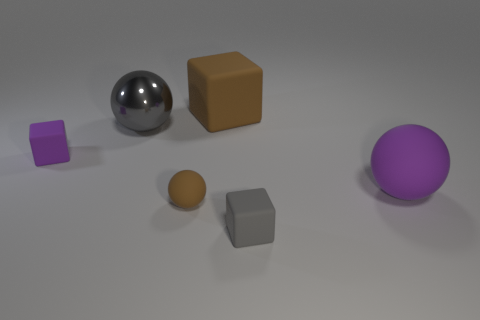Add 4 small brown metal cylinders. How many objects exist? 10 Add 5 brown rubber blocks. How many brown rubber blocks are left? 6 Add 5 rubber cubes. How many rubber cubes exist? 8 Subtract 0 red blocks. How many objects are left? 6 Subtract all big yellow shiny blocks. Subtract all big gray shiny spheres. How many objects are left? 5 